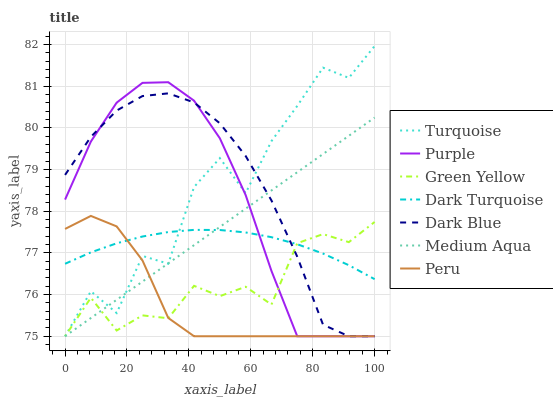Does Peru have the minimum area under the curve?
Answer yes or no. Yes. Does Dark Blue have the maximum area under the curve?
Answer yes or no. Yes. Does Purple have the minimum area under the curve?
Answer yes or no. No. Does Purple have the maximum area under the curve?
Answer yes or no. No. Is Medium Aqua the smoothest?
Answer yes or no. Yes. Is Turquoise the roughest?
Answer yes or no. Yes. Is Purple the smoothest?
Answer yes or no. No. Is Purple the roughest?
Answer yes or no. No. Does Turquoise have the lowest value?
Answer yes or no. Yes. Does Dark Turquoise have the lowest value?
Answer yes or no. No. Does Turquoise have the highest value?
Answer yes or no. Yes. Does Purple have the highest value?
Answer yes or no. No. Does Peru intersect Purple?
Answer yes or no. Yes. Is Peru less than Purple?
Answer yes or no. No. Is Peru greater than Purple?
Answer yes or no. No. 